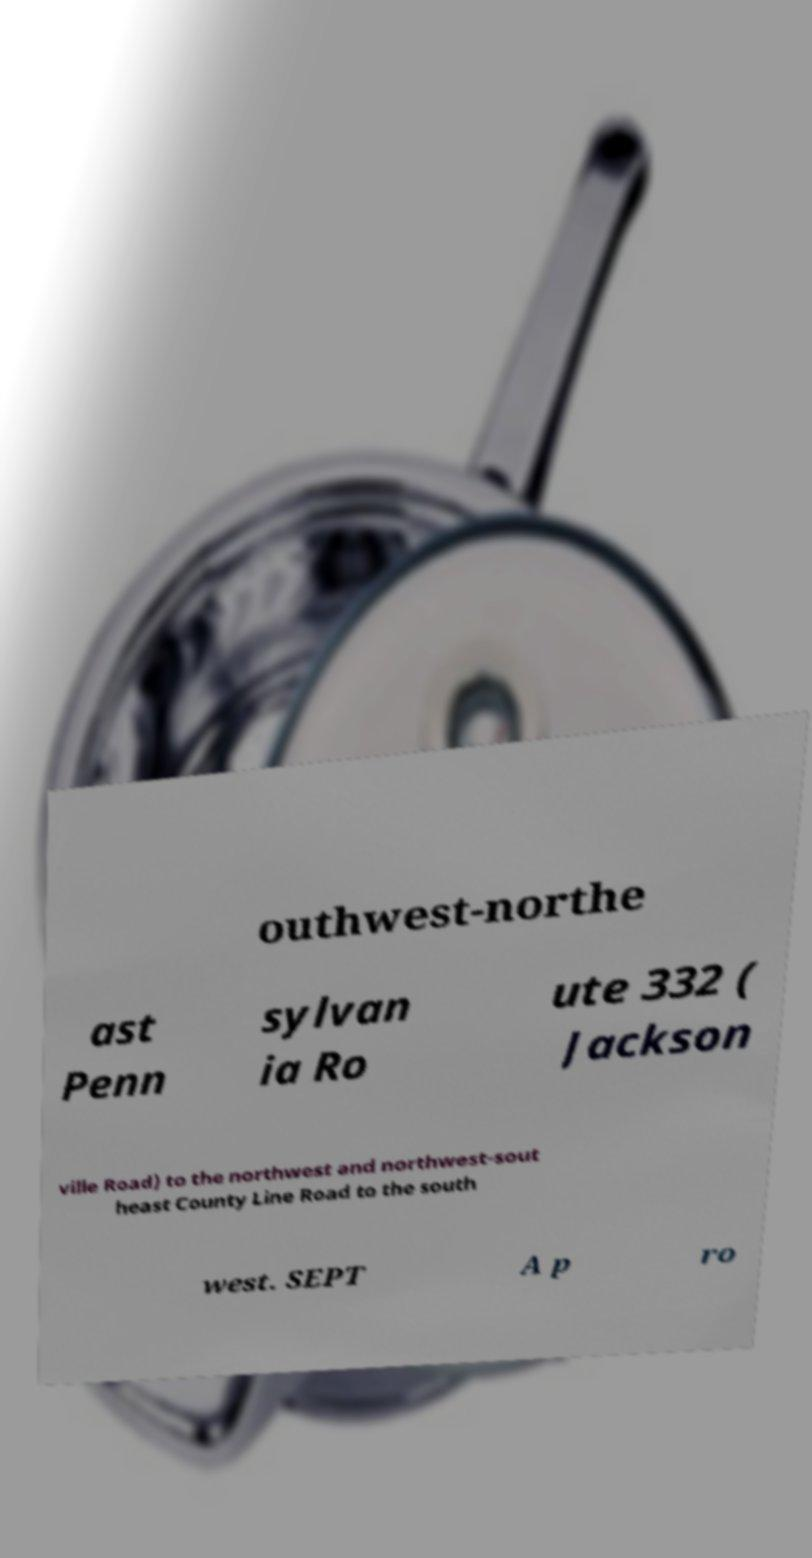There's text embedded in this image that I need extracted. Can you transcribe it verbatim? outhwest-northe ast Penn sylvan ia Ro ute 332 ( Jackson ville Road) to the northwest and northwest-sout heast County Line Road to the south west. SEPT A p ro 